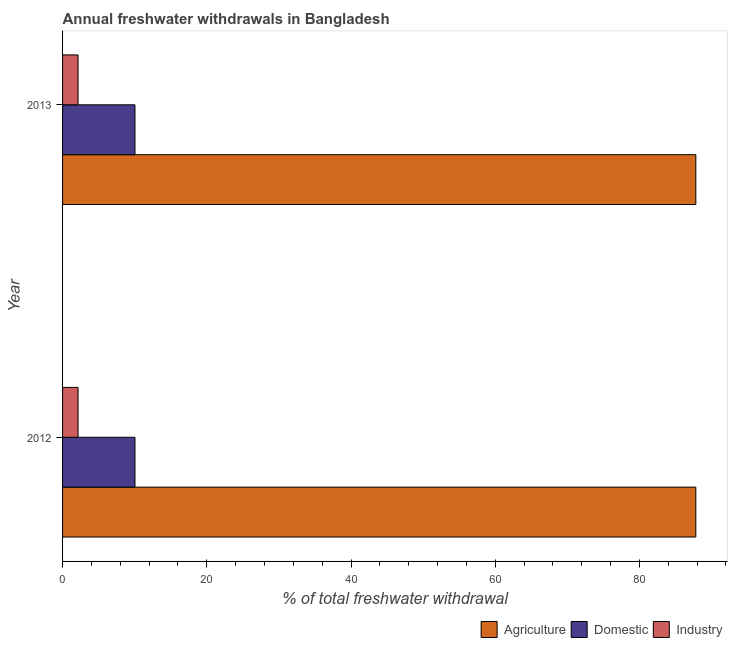How many different coloured bars are there?
Keep it short and to the point. 3. Are the number of bars on each tick of the Y-axis equal?
Offer a terse response. Yes. How many bars are there on the 1st tick from the bottom?
Ensure brevity in your answer.  3. What is the label of the 2nd group of bars from the top?
Offer a very short reply. 2012. In how many cases, is the number of bars for a given year not equal to the number of legend labels?
Provide a short and direct response. 0. What is the percentage of freshwater withdrawal for domestic purposes in 2012?
Keep it short and to the point. 10.04. Across all years, what is the maximum percentage of freshwater withdrawal for domestic purposes?
Provide a succinct answer. 10.04. Across all years, what is the minimum percentage of freshwater withdrawal for agriculture?
Make the answer very short. 87.82. In which year was the percentage of freshwater withdrawal for industry maximum?
Give a very brief answer. 2012. In which year was the percentage of freshwater withdrawal for agriculture minimum?
Ensure brevity in your answer.  2012. What is the total percentage of freshwater withdrawal for agriculture in the graph?
Offer a very short reply. 175.64. What is the difference between the percentage of freshwater withdrawal for agriculture in 2012 and that in 2013?
Your answer should be very brief. 0. What is the difference between the percentage of freshwater withdrawal for domestic purposes in 2013 and the percentage of freshwater withdrawal for industry in 2012?
Offer a terse response. 7.89. What is the average percentage of freshwater withdrawal for agriculture per year?
Offer a very short reply. 87.82. In the year 2013, what is the difference between the percentage of freshwater withdrawal for domestic purposes and percentage of freshwater withdrawal for industry?
Ensure brevity in your answer.  7.89. What does the 1st bar from the top in 2012 represents?
Keep it short and to the point. Industry. What does the 1st bar from the bottom in 2013 represents?
Offer a terse response. Agriculture. Is it the case that in every year, the sum of the percentage of freshwater withdrawal for agriculture and percentage of freshwater withdrawal for domestic purposes is greater than the percentage of freshwater withdrawal for industry?
Your answer should be compact. Yes. How many bars are there?
Provide a short and direct response. 6. Are all the bars in the graph horizontal?
Your answer should be compact. Yes. How many years are there in the graph?
Your response must be concise. 2. Are the values on the major ticks of X-axis written in scientific E-notation?
Offer a very short reply. No. Does the graph contain grids?
Your answer should be compact. No. Where does the legend appear in the graph?
Make the answer very short. Bottom right. How are the legend labels stacked?
Offer a very short reply. Horizontal. What is the title of the graph?
Ensure brevity in your answer.  Annual freshwater withdrawals in Bangladesh. Does "Self-employed" appear as one of the legend labels in the graph?
Your answer should be very brief. No. What is the label or title of the X-axis?
Offer a very short reply. % of total freshwater withdrawal. What is the label or title of the Y-axis?
Give a very brief answer. Year. What is the % of total freshwater withdrawal in Agriculture in 2012?
Your answer should be compact. 87.82. What is the % of total freshwater withdrawal of Domestic in 2012?
Provide a short and direct response. 10.04. What is the % of total freshwater withdrawal in Industry in 2012?
Ensure brevity in your answer.  2.15. What is the % of total freshwater withdrawal of Agriculture in 2013?
Ensure brevity in your answer.  87.82. What is the % of total freshwater withdrawal of Domestic in 2013?
Keep it short and to the point. 10.04. What is the % of total freshwater withdrawal of Industry in 2013?
Your answer should be compact. 2.15. Across all years, what is the maximum % of total freshwater withdrawal of Agriculture?
Offer a terse response. 87.82. Across all years, what is the maximum % of total freshwater withdrawal in Domestic?
Your answer should be compact. 10.04. Across all years, what is the maximum % of total freshwater withdrawal of Industry?
Your answer should be compact. 2.15. Across all years, what is the minimum % of total freshwater withdrawal in Agriculture?
Your answer should be compact. 87.82. Across all years, what is the minimum % of total freshwater withdrawal of Domestic?
Your response must be concise. 10.04. Across all years, what is the minimum % of total freshwater withdrawal of Industry?
Keep it short and to the point. 2.15. What is the total % of total freshwater withdrawal in Agriculture in the graph?
Your answer should be very brief. 175.64. What is the total % of total freshwater withdrawal of Domestic in the graph?
Offer a terse response. 20.08. What is the total % of total freshwater withdrawal in Industry in the graph?
Offer a very short reply. 4.29. What is the difference between the % of total freshwater withdrawal in Domestic in 2012 and that in 2013?
Provide a short and direct response. 0. What is the difference between the % of total freshwater withdrawal in Industry in 2012 and that in 2013?
Provide a short and direct response. 0. What is the difference between the % of total freshwater withdrawal in Agriculture in 2012 and the % of total freshwater withdrawal in Domestic in 2013?
Make the answer very short. 77.78. What is the difference between the % of total freshwater withdrawal in Agriculture in 2012 and the % of total freshwater withdrawal in Industry in 2013?
Your answer should be very brief. 85.67. What is the difference between the % of total freshwater withdrawal of Domestic in 2012 and the % of total freshwater withdrawal of Industry in 2013?
Provide a succinct answer. 7.89. What is the average % of total freshwater withdrawal of Agriculture per year?
Give a very brief answer. 87.82. What is the average % of total freshwater withdrawal of Domestic per year?
Make the answer very short. 10.04. What is the average % of total freshwater withdrawal of Industry per year?
Your answer should be compact. 2.15. In the year 2012, what is the difference between the % of total freshwater withdrawal of Agriculture and % of total freshwater withdrawal of Domestic?
Offer a very short reply. 77.78. In the year 2012, what is the difference between the % of total freshwater withdrawal in Agriculture and % of total freshwater withdrawal in Industry?
Offer a terse response. 85.67. In the year 2012, what is the difference between the % of total freshwater withdrawal in Domestic and % of total freshwater withdrawal in Industry?
Make the answer very short. 7.89. In the year 2013, what is the difference between the % of total freshwater withdrawal in Agriculture and % of total freshwater withdrawal in Domestic?
Keep it short and to the point. 77.78. In the year 2013, what is the difference between the % of total freshwater withdrawal of Agriculture and % of total freshwater withdrawal of Industry?
Keep it short and to the point. 85.67. In the year 2013, what is the difference between the % of total freshwater withdrawal in Domestic and % of total freshwater withdrawal in Industry?
Your answer should be very brief. 7.89. What is the ratio of the % of total freshwater withdrawal of Agriculture in 2012 to that in 2013?
Offer a terse response. 1. What is the ratio of the % of total freshwater withdrawal of Industry in 2012 to that in 2013?
Keep it short and to the point. 1. What is the difference between the highest and the second highest % of total freshwater withdrawal in Agriculture?
Offer a very short reply. 0. What is the difference between the highest and the second highest % of total freshwater withdrawal of Industry?
Give a very brief answer. 0. What is the difference between the highest and the lowest % of total freshwater withdrawal in Domestic?
Your response must be concise. 0. 